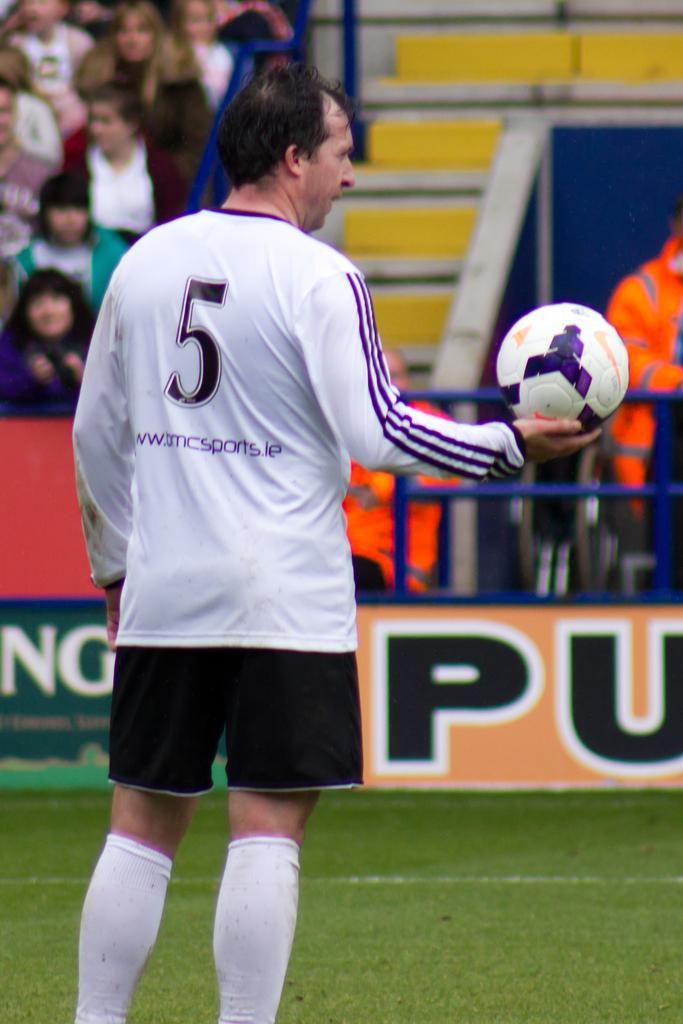Can you describe this image briefly? In this Image I see a man who is on the grass and he is wearing a jersey and I can also see he is holding a ball, In the background I see people who are sitting on chairs and I see the steps over here. 